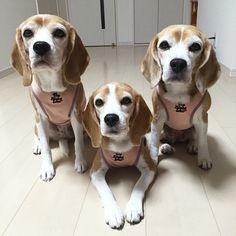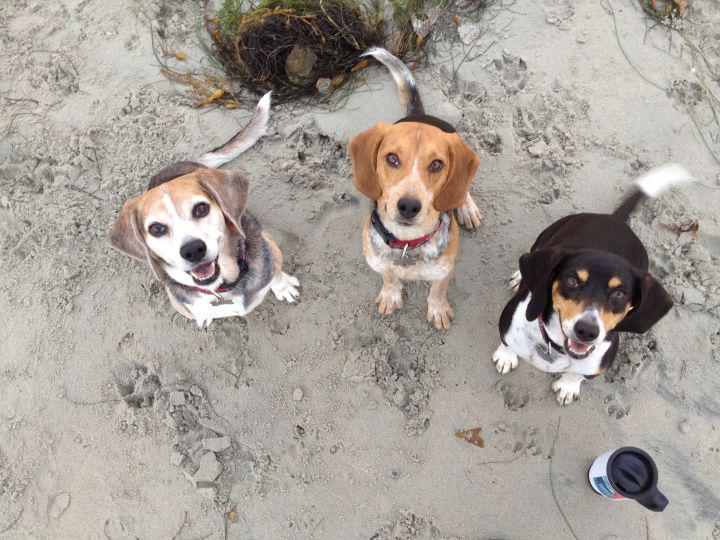The first image is the image on the left, the second image is the image on the right. Examine the images to the left and right. Is the description "There are at least two dogs in the left image." accurate? Answer yes or no. Yes. The first image is the image on the left, the second image is the image on the right. Examine the images to the left and right. Is the description "All dogs are looking up at the camera, at least one dog has an open mouth, and no image contains more than two dogs." accurate? Answer yes or no. No. 